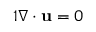<formula> <loc_0><loc_0><loc_500><loc_500>\begin{array} { r } { { 1 } \nabla \cdot u = 0 } \end{array}</formula> 